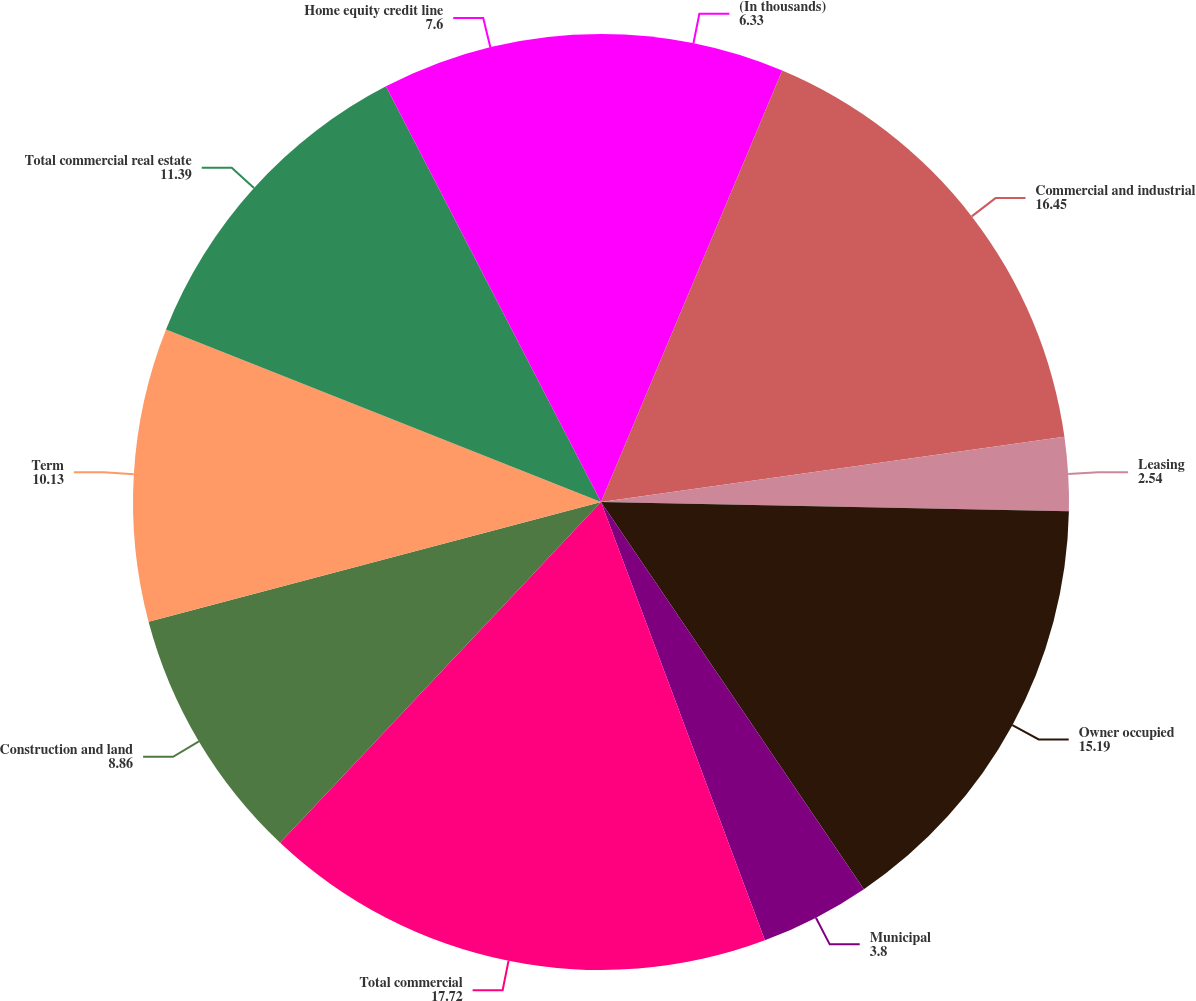Convert chart to OTSL. <chart><loc_0><loc_0><loc_500><loc_500><pie_chart><fcel>(In thousands)<fcel>Commercial and industrial<fcel>Leasing<fcel>Owner occupied<fcel>Municipal<fcel>Total commercial<fcel>Construction and land<fcel>Term<fcel>Total commercial real estate<fcel>Home equity credit line<nl><fcel>6.33%<fcel>16.45%<fcel>2.54%<fcel>15.19%<fcel>3.8%<fcel>17.72%<fcel>8.86%<fcel>10.13%<fcel>11.39%<fcel>7.6%<nl></chart> 